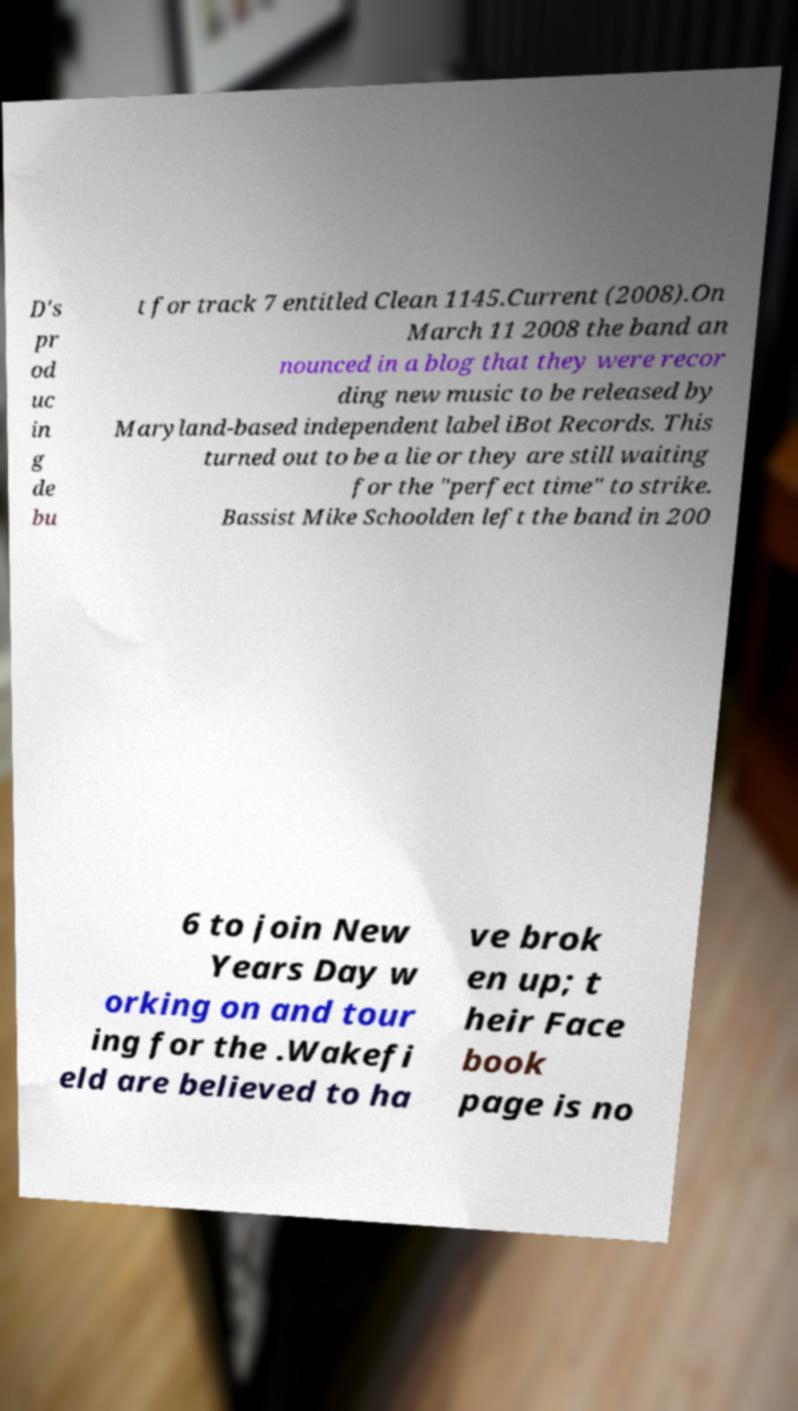Please read and relay the text visible in this image. What does it say? D's pr od uc in g de bu t for track 7 entitled Clean 1145.Current (2008).On March 11 2008 the band an nounced in a blog that they were recor ding new music to be released by Maryland-based independent label iBot Records. This turned out to be a lie or they are still waiting for the "perfect time" to strike. Bassist Mike Schoolden left the band in 200 6 to join New Years Day w orking on and tour ing for the .Wakefi eld are believed to ha ve brok en up; t heir Face book page is no 